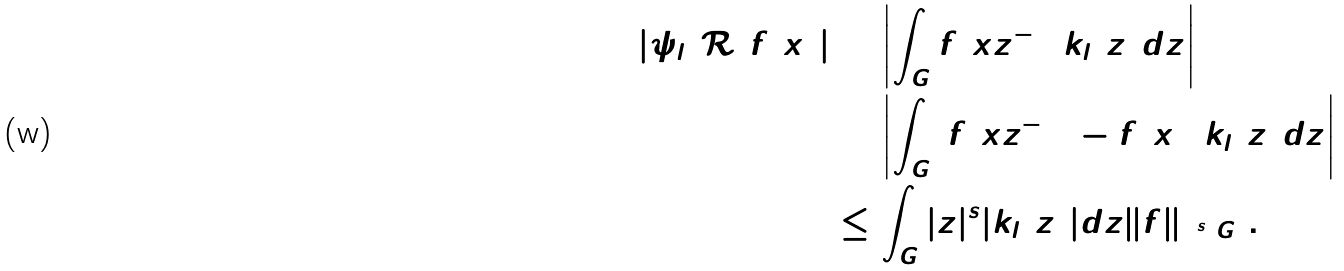<formula> <loc_0><loc_0><loc_500><loc_500>| \psi _ { l } ( \mathcal { R } ) f ( x ) | & = \left | \int _ { G } f ( x z ^ { - 1 } ) k _ { l } ( z ) d z \right | \\ & = \left | \int _ { G } ( f ( x z ^ { - 1 } ) - f ( x ) ) k _ { l } ( z ) d z \right | \\ & \leq \int _ { G } | z | ^ { s } | k _ { l } ( z ) | d z \| f \| _ { \Lambda ^ { s } ( G ) } .</formula> 